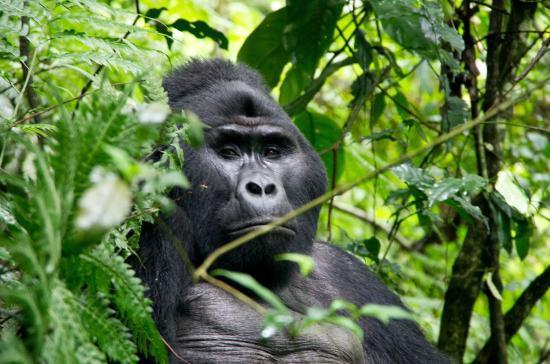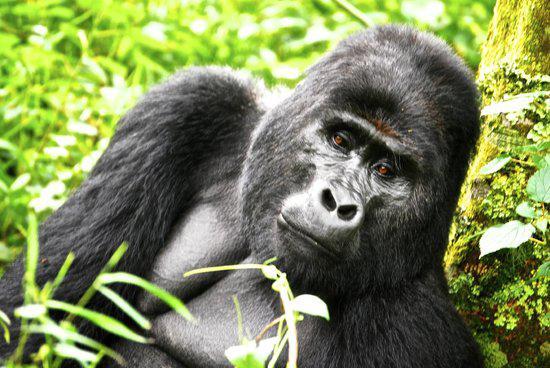The first image is the image on the left, the second image is the image on the right. Analyze the images presented: Is the assertion "In the right image, multiple people are near an adult gorilla, and at least one person is holding up a camera." valid? Answer yes or no. No. The first image is the image on the left, the second image is the image on the right. Examine the images to the left and right. Is the description "There are humans taking pictures of apes in one of the images." accurate? Answer yes or no. No. 